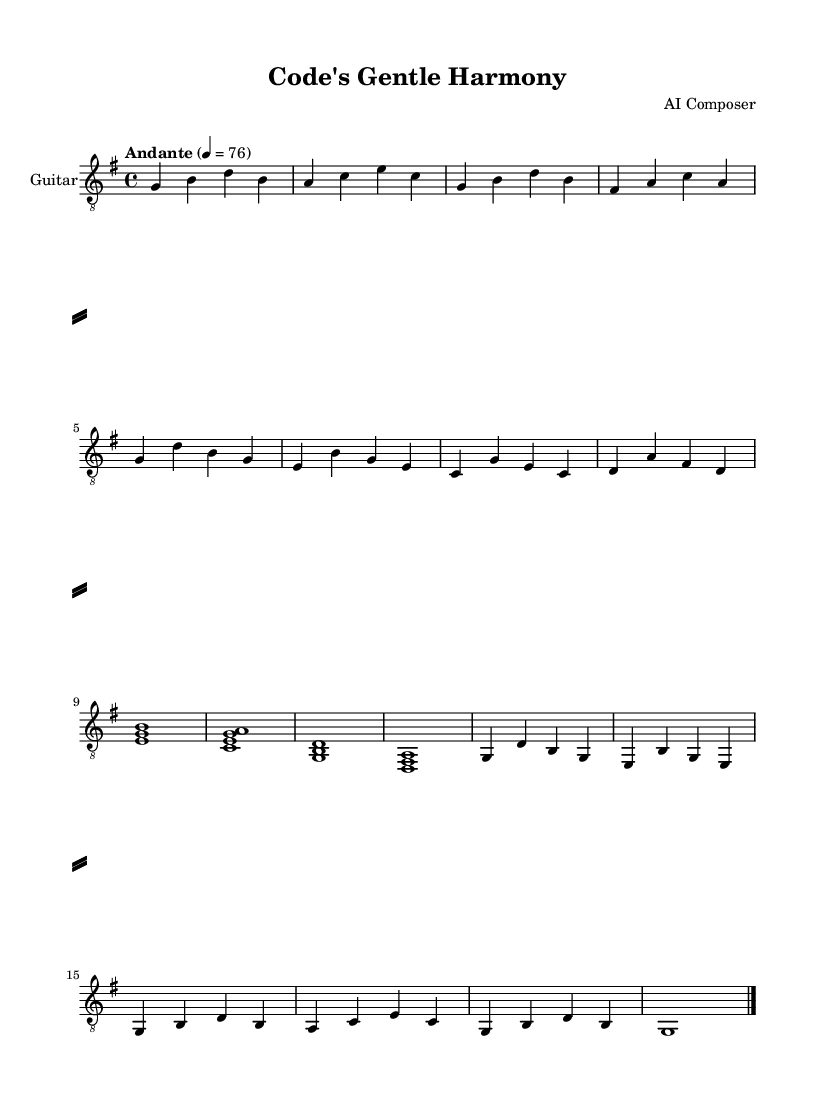What is the key signature of this music? The key signature is indicated by the presence of the sharp symbol on the F line, which is seen in the music sheet. This corresponds to the key of G major, which contains one sharp.
Answer: G major What is the time signature of this music? The time signature is presented at the beginning of the score as 4/4, indicating there are four beats in each measure and a quarter note receives one beat.
Answer: 4/4 What is the tempo of this piece? The tempo marking "Andante" indicates a moderate pace, and 4 equals 76 means that there are 76 beats per minute. This combination gives us the tempo.
Answer: Andante, 76 How many measures are there in the Verse section? By reviewing the music, we notice two instances of the Verse structure, each containing four measures. Thus, calculating gives us a total of eight measures in the Verse.
Answer: 8 What is the primary instrument for this score? The instrument is specified in the staff details with the note "Guitar" and specifically mentions "acoustic guitar (nylon)" as the MIDI instrument, indicating this is the primary instrument for the piece.
Answer: Guitar What are the first four notes of the Intro? By inspecting the sheet music, we can see that the Intro begins with the notes G, B, D, and B. These notes are positioned in the first measure of the Intro section.
Answer: G, B, D, B What is the last note of the Outro? The last note in the Outro section is a G note, which is seen at the end of the music after the last bar. It is held out as a whole note, indicating its importance as a closing note.
Answer: G 